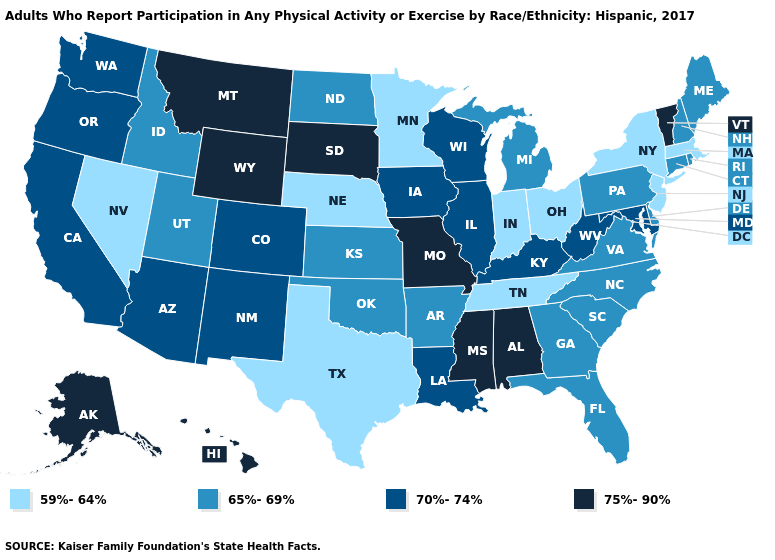Among the states that border West Virginia , does Kentucky have the lowest value?
Write a very short answer. No. Name the states that have a value in the range 59%-64%?
Keep it brief. Indiana, Massachusetts, Minnesota, Nebraska, Nevada, New Jersey, New York, Ohio, Tennessee, Texas. Name the states that have a value in the range 75%-90%?
Short answer required. Alabama, Alaska, Hawaii, Mississippi, Missouri, Montana, South Dakota, Vermont, Wyoming. Does the map have missing data?
Give a very brief answer. No. Which states have the highest value in the USA?
Write a very short answer. Alabama, Alaska, Hawaii, Mississippi, Missouri, Montana, South Dakota, Vermont, Wyoming. Does the first symbol in the legend represent the smallest category?
Quick response, please. Yes. What is the value of North Carolina?
Give a very brief answer. 65%-69%. Name the states that have a value in the range 59%-64%?
Be succinct. Indiana, Massachusetts, Minnesota, Nebraska, Nevada, New Jersey, New York, Ohio, Tennessee, Texas. Among the states that border Indiana , which have the lowest value?
Keep it brief. Ohio. Name the states that have a value in the range 75%-90%?
Give a very brief answer. Alabama, Alaska, Hawaii, Mississippi, Missouri, Montana, South Dakota, Vermont, Wyoming. What is the value of New Mexico?
Answer briefly. 70%-74%. Does the first symbol in the legend represent the smallest category?
Concise answer only. Yes. Name the states that have a value in the range 75%-90%?
Be succinct. Alabama, Alaska, Hawaii, Mississippi, Missouri, Montana, South Dakota, Vermont, Wyoming. Name the states that have a value in the range 75%-90%?
Quick response, please. Alabama, Alaska, Hawaii, Mississippi, Missouri, Montana, South Dakota, Vermont, Wyoming. What is the value of Alabama?
Write a very short answer. 75%-90%. 